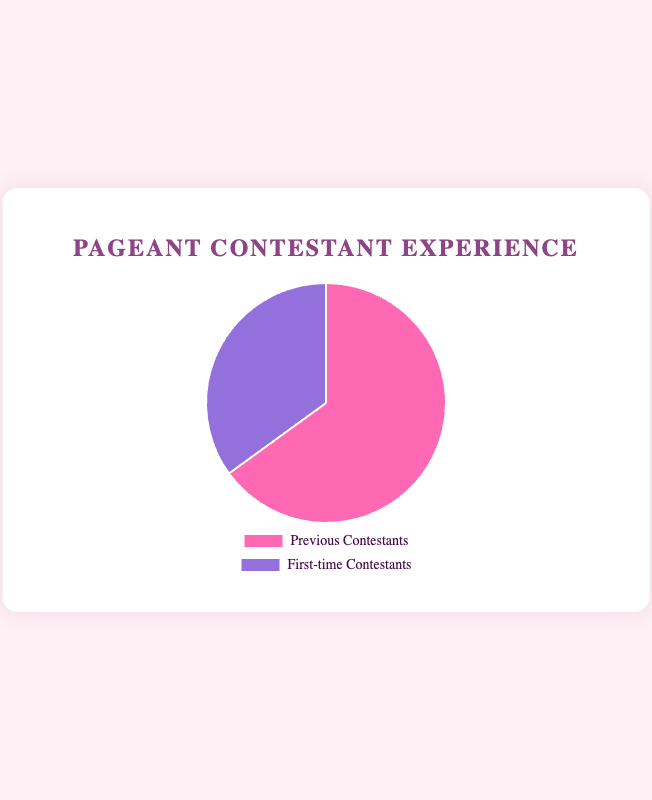What percentage of contestants are participating for the first time? The pie chart shows a segment labeled "First-time Contestants" with a corresponding percentage value next to it. By identifying this segment, we see that the percentage for first-time contestants is provided as 35%.
Answer: 35% Which group has a higher percentage of participants, previous contestants or first-time contestants? By comparing the two segments in the pie chart, "Previous Contestants" shows 65% and "First-time Contestants" shows 35%. The former is greater.
Answer: Previous Contestants What is the difference in the percentage of previous contestants and first-time contestants? Subtract the percentage of first-time contestants from the percentage of previous contestants: 65% - 35%.
Answer: 30% How much larger is the percentage of previous contestants compared to first-time contestants? Calculate the ratio of the difference to the percentage of first-time contestants: (65% - 35%) / 35%, which is approximately 0.857 or 85.7%.
Answer: 85.7% If there are 200 contestants in total, how many of them are first-time contestants? Calculate 35% of 200 (0.35 * 200): 70 contestants.
Answer: 70 What color represents the "First-time Contestants" segment in the chart? Look for the visual attributes of the pie chart to identify the color specified for "First-time Contestants." It is described as purple in the code, which would be indicated visually.
Answer: Purple How many more contestants have participated in pageants previously compared to first-time contestants, if there are 200 contestants in total? First, calculate the number of previous contestants (65% of 200) and first-time contestants (35% of 200): 130 - 70 = 60 contestants.
Answer: 60 